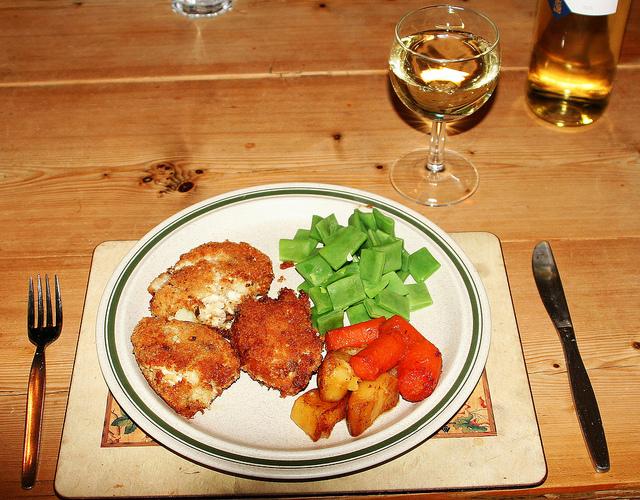What is in the glass?
Keep it brief. Wine. What might the eater of this meal be planning to do while eating?
Give a very brief answer. Drinking. What does the food look like?
Concise answer only. Mushy. Do you see a spoon?
Concise answer only. No. What side is the fork on?
Short answer required. Left. 